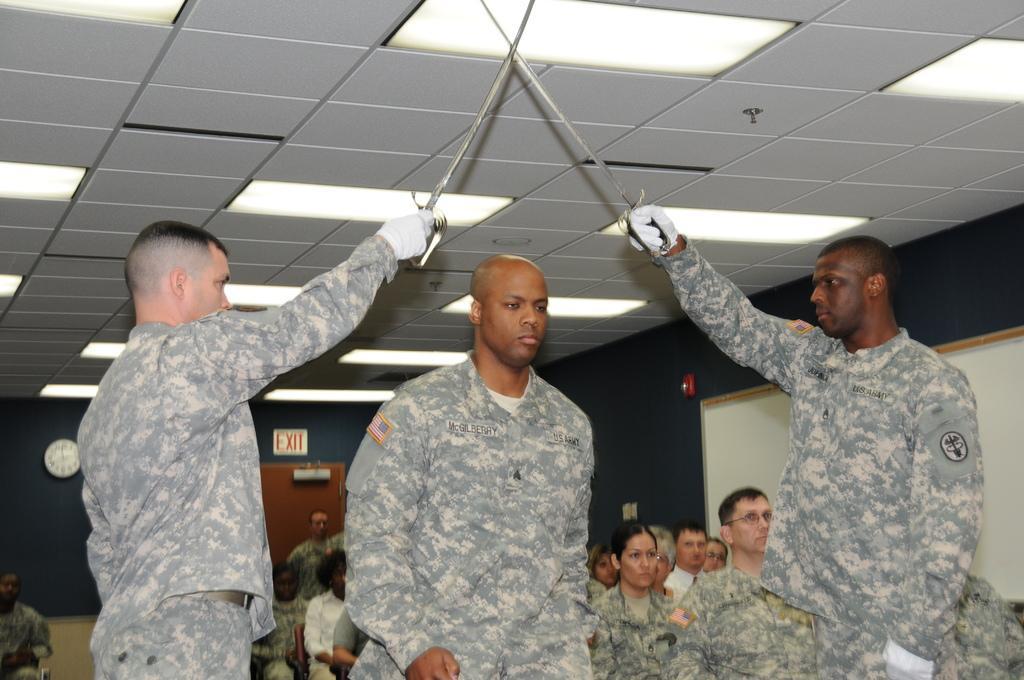Please provide a concise description of this image. In this image I can see some people. In the background, I can see the wall with some text written on it. At the top I can see the lights. 